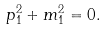Convert formula to latex. <formula><loc_0><loc_0><loc_500><loc_500>p _ { 1 } ^ { 2 } + m _ { 1 } ^ { 2 } = 0 .</formula> 